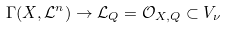Convert formula to latex. <formula><loc_0><loc_0><loc_500><loc_500>\Gamma ( X , \mathcal { L } ^ { n } ) \rightarrow \mathcal { L } _ { Q } = \mathcal { O } _ { X , Q } \subset V _ { \nu }</formula> 